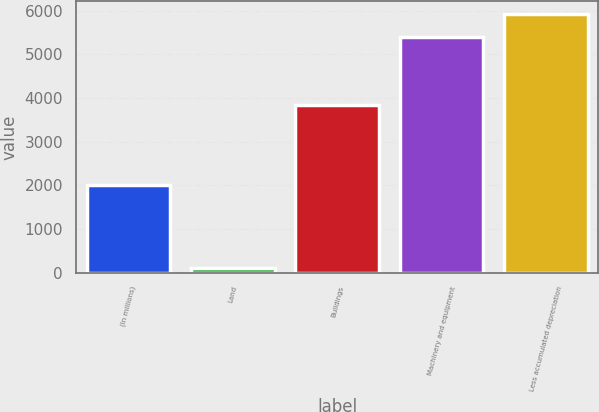Convert chart to OTSL. <chart><loc_0><loc_0><loc_500><loc_500><bar_chart><fcel>(In millions)<fcel>Land<fcel>Buildings<fcel>Machinery and equipment<fcel>Less accumulated depreciation<nl><fcel>2005<fcel>112<fcel>3828<fcel>5384<fcel>5912.8<nl></chart> 